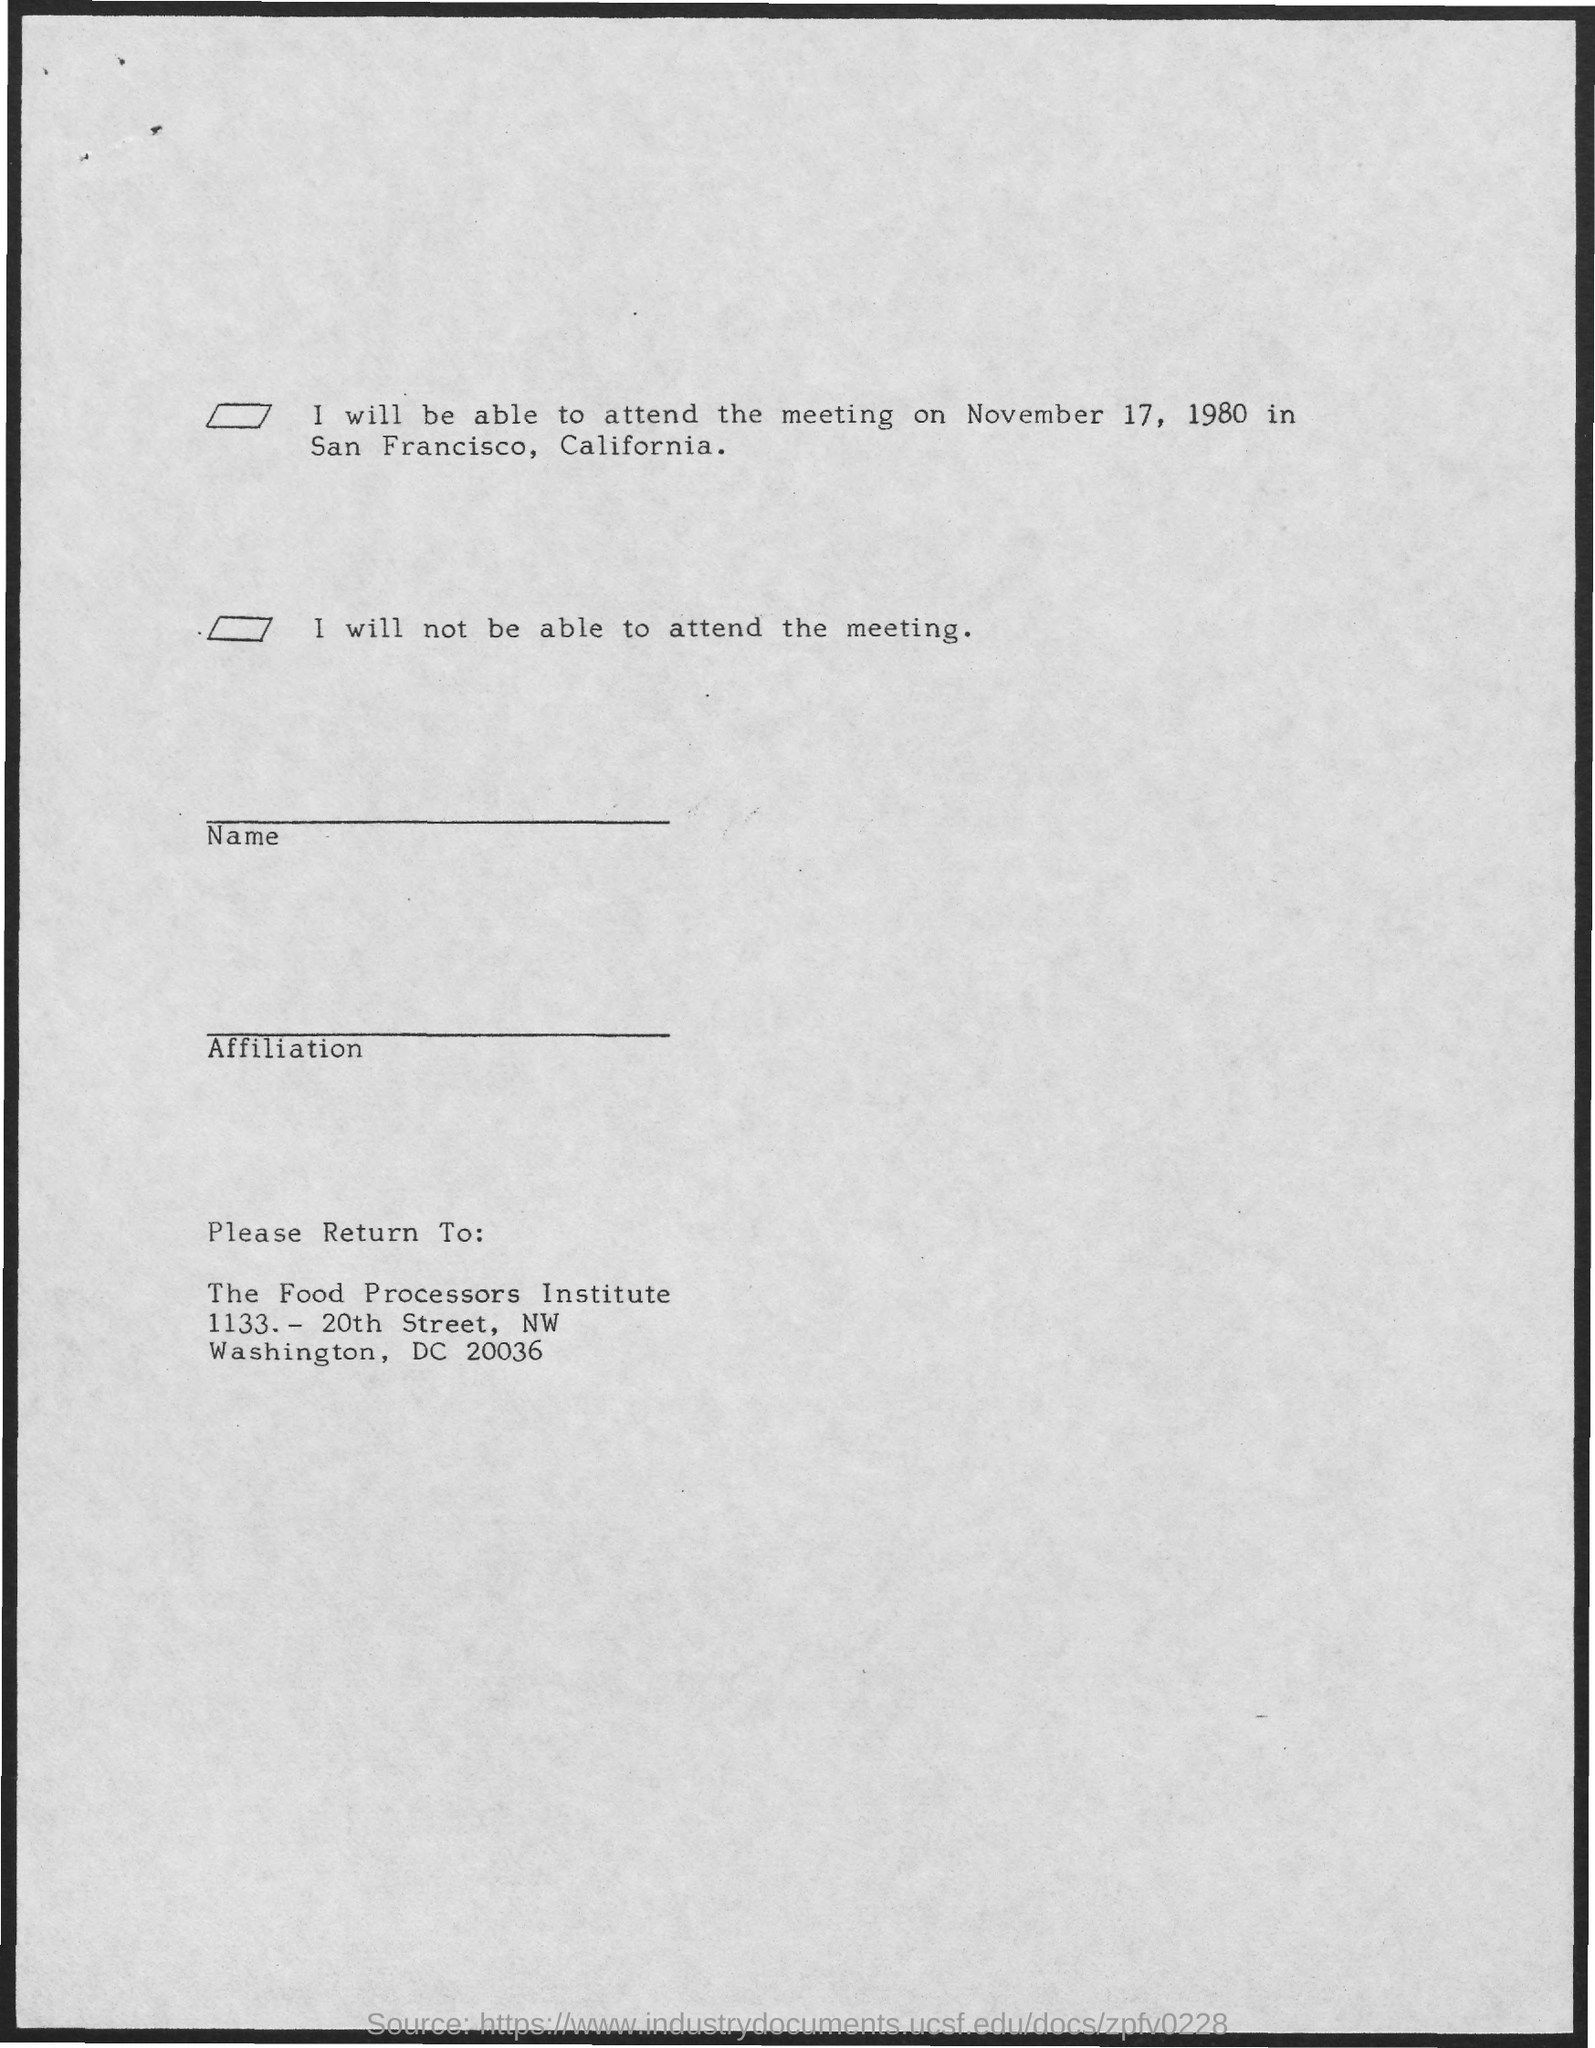Highlight a few significant elements in this photo. San Francisco is located in the state of California. The meeting date can be found on the page, and it is November 17, 1980. The Food Processors Institute is the name of the institute. 